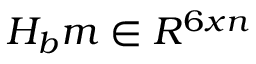<formula> <loc_0><loc_0><loc_500><loc_500>H _ { b } m \in R ^ { 6 x n }</formula> 